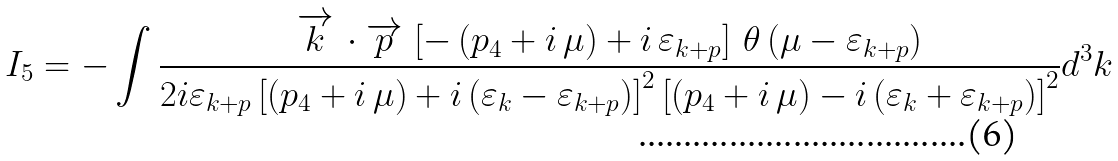Convert formula to latex. <formula><loc_0><loc_0><loc_500><loc_500>I _ { 5 } = - \int \frac { \overrightarrow { k } \, \cdot \overrightarrow { p } \, \left [ - \left ( p _ { 4 } + i \, \mu \right ) + i \, \varepsilon _ { k + p } \right ] \, { \theta } \left ( \mu - \varepsilon _ { k + p } \right ) } { 2 i \varepsilon _ { k + p } \left [ \left ( p _ { 4 } + i \, \mu \right ) + i \left ( \varepsilon _ { k } - \varepsilon _ { k + p } \right ) \right ] ^ { 2 } \left [ \left ( p _ { 4 } + i \, \mu \right ) - i \left ( \varepsilon _ { k } + \varepsilon _ { k + p } \right ) \right ] ^ { 2 } } d ^ { 3 } k</formula> 